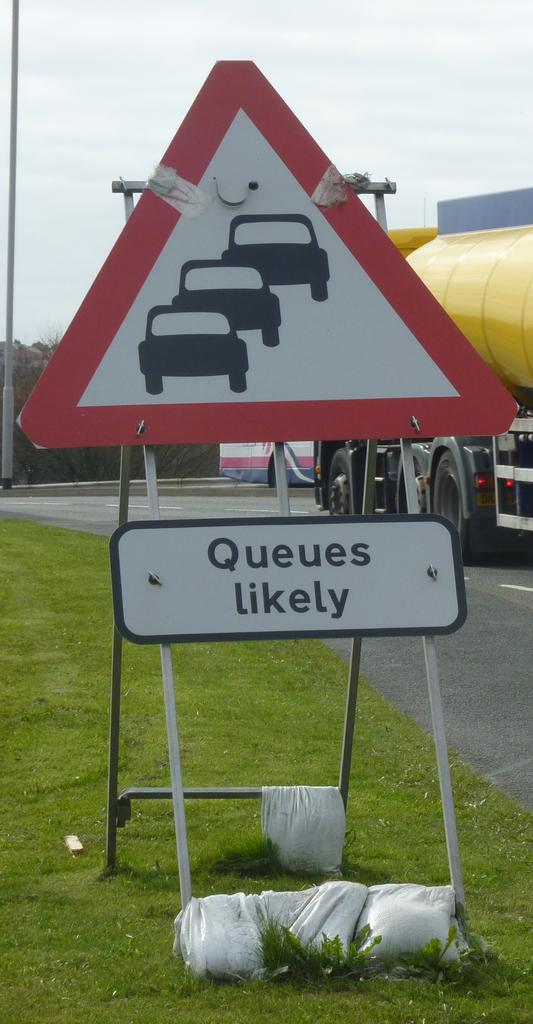<image>
Relay a brief, clear account of the picture shown. A red and white triangular road sign which has a sign reading Queues likely underneath. 